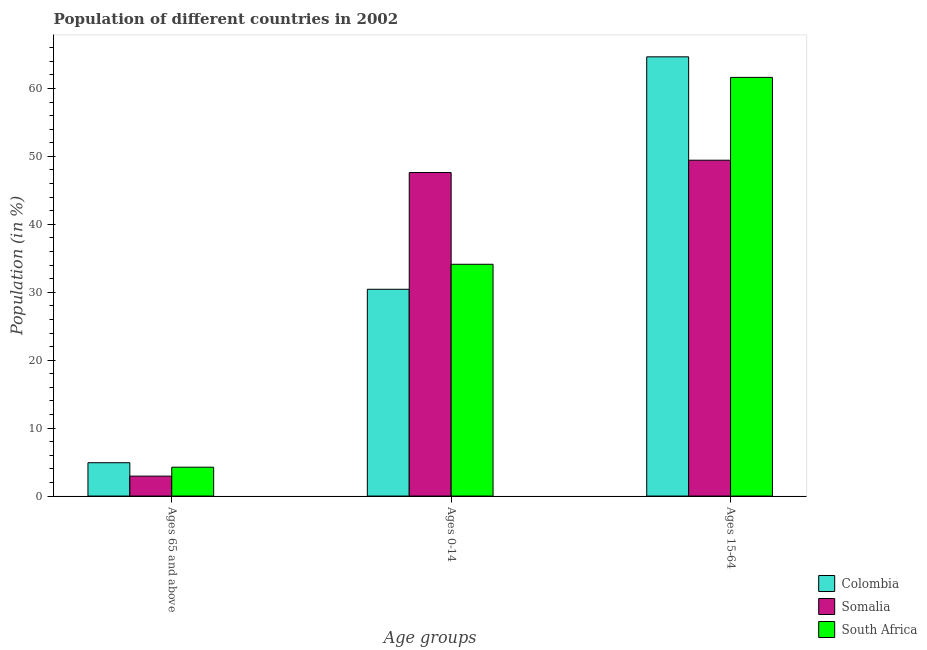How many different coloured bars are there?
Provide a short and direct response. 3. How many bars are there on the 2nd tick from the left?
Make the answer very short. 3. How many bars are there on the 3rd tick from the right?
Keep it short and to the point. 3. What is the label of the 2nd group of bars from the left?
Your answer should be compact. Ages 0-14. What is the percentage of population within the age-group of 65 and above in Somalia?
Ensure brevity in your answer.  2.94. Across all countries, what is the maximum percentage of population within the age-group 0-14?
Provide a succinct answer. 47.63. Across all countries, what is the minimum percentage of population within the age-group of 65 and above?
Ensure brevity in your answer.  2.94. In which country was the percentage of population within the age-group 0-14 maximum?
Make the answer very short. Somalia. In which country was the percentage of population within the age-group 0-14 minimum?
Your answer should be very brief. Colombia. What is the total percentage of population within the age-group 0-14 in the graph?
Your answer should be compact. 112.18. What is the difference between the percentage of population within the age-group of 65 and above in South Africa and that in Colombia?
Your answer should be very brief. -0.66. What is the difference between the percentage of population within the age-group of 65 and above in South Africa and the percentage of population within the age-group 0-14 in Colombia?
Offer a very short reply. -26.19. What is the average percentage of population within the age-group 0-14 per country?
Make the answer very short. 37.39. What is the difference between the percentage of population within the age-group 15-64 and percentage of population within the age-group of 65 and above in South Africa?
Your answer should be compact. 57.38. In how many countries, is the percentage of population within the age-group of 65 and above greater than 54 %?
Make the answer very short. 0. What is the ratio of the percentage of population within the age-group of 65 and above in South Africa to that in Colombia?
Ensure brevity in your answer.  0.87. Is the percentage of population within the age-group 0-14 in Colombia less than that in South Africa?
Provide a short and direct response. Yes. Is the difference between the percentage of population within the age-group 0-14 in South Africa and Somalia greater than the difference between the percentage of population within the age-group of 65 and above in South Africa and Somalia?
Keep it short and to the point. No. What is the difference between the highest and the second highest percentage of population within the age-group 15-64?
Give a very brief answer. 3.02. What is the difference between the highest and the lowest percentage of population within the age-group of 65 and above?
Keep it short and to the point. 1.97. What does the 2nd bar from the left in Ages 65 and above represents?
Keep it short and to the point. Somalia. What does the 2nd bar from the right in Ages 15-64 represents?
Your answer should be very brief. Somalia. Are all the bars in the graph horizontal?
Your answer should be compact. No. How many countries are there in the graph?
Your answer should be very brief. 3. Are the values on the major ticks of Y-axis written in scientific E-notation?
Keep it short and to the point. No. Where does the legend appear in the graph?
Your response must be concise. Bottom right. How many legend labels are there?
Keep it short and to the point. 3. What is the title of the graph?
Keep it short and to the point. Population of different countries in 2002. What is the label or title of the X-axis?
Your answer should be very brief. Age groups. What is the label or title of the Y-axis?
Offer a terse response. Population (in %). What is the Population (in %) of Colombia in Ages 65 and above?
Offer a terse response. 4.91. What is the Population (in %) of Somalia in Ages 65 and above?
Offer a terse response. 2.94. What is the Population (in %) in South Africa in Ages 65 and above?
Offer a very short reply. 4.25. What is the Population (in %) in Colombia in Ages 0-14?
Your answer should be very brief. 30.44. What is the Population (in %) of Somalia in Ages 0-14?
Give a very brief answer. 47.63. What is the Population (in %) in South Africa in Ages 0-14?
Provide a short and direct response. 34.12. What is the Population (in %) in Colombia in Ages 15-64?
Offer a terse response. 64.65. What is the Population (in %) in Somalia in Ages 15-64?
Keep it short and to the point. 49.44. What is the Population (in %) of South Africa in Ages 15-64?
Give a very brief answer. 61.63. Across all Age groups, what is the maximum Population (in %) of Colombia?
Your answer should be very brief. 64.65. Across all Age groups, what is the maximum Population (in %) of Somalia?
Your response must be concise. 49.44. Across all Age groups, what is the maximum Population (in %) in South Africa?
Your answer should be compact. 61.63. Across all Age groups, what is the minimum Population (in %) of Colombia?
Ensure brevity in your answer.  4.91. Across all Age groups, what is the minimum Population (in %) of Somalia?
Your answer should be very brief. 2.94. Across all Age groups, what is the minimum Population (in %) in South Africa?
Offer a terse response. 4.25. What is the total Population (in %) in Somalia in the graph?
Ensure brevity in your answer.  100. What is the total Population (in %) in South Africa in the graph?
Your answer should be very brief. 100. What is the difference between the Population (in %) in Colombia in Ages 65 and above and that in Ages 0-14?
Your response must be concise. -25.53. What is the difference between the Population (in %) of Somalia in Ages 65 and above and that in Ages 0-14?
Offer a terse response. -44.69. What is the difference between the Population (in %) in South Africa in Ages 65 and above and that in Ages 0-14?
Your response must be concise. -29.87. What is the difference between the Population (in %) of Colombia in Ages 65 and above and that in Ages 15-64?
Offer a very short reply. -59.75. What is the difference between the Population (in %) of Somalia in Ages 65 and above and that in Ages 15-64?
Provide a succinct answer. -46.5. What is the difference between the Population (in %) in South Africa in Ages 65 and above and that in Ages 15-64?
Offer a terse response. -57.38. What is the difference between the Population (in %) in Colombia in Ages 0-14 and that in Ages 15-64?
Offer a very short reply. -34.22. What is the difference between the Population (in %) in Somalia in Ages 0-14 and that in Ages 15-64?
Give a very brief answer. -1.81. What is the difference between the Population (in %) of South Africa in Ages 0-14 and that in Ages 15-64?
Offer a terse response. -27.51. What is the difference between the Population (in %) of Colombia in Ages 65 and above and the Population (in %) of Somalia in Ages 0-14?
Ensure brevity in your answer.  -42.72. What is the difference between the Population (in %) in Colombia in Ages 65 and above and the Population (in %) in South Africa in Ages 0-14?
Keep it short and to the point. -29.21. What is the difference between the Population (in %) of Somalia in Ages 65 and above and the Population (in %) of South Africa in Ages 0-14?
Provide a short and direct response. -31.18. What is the difference between the Population (in %) in Colombia in Ages 65 and above and the Population (in %) in Somalia in Ages 15-64?
Your answer should be very brief. -44.53. What is the difference between the Population (in %) in Colombia in Ages 65 and above and the Population (in %) in South Africa in Ages 15-64?
Keep it short and to the point. -56.72. What is the difference between the Population (in %) of Somalia in Ages 65 and above and the Population (in %) of South Africa in Ages 15-64?
Your answer should be very brief. -58.69. What is the difference between the Population (in %) in Colombia in Ages 0-14 and the Population (in %) in Somalia in Ages 15-64?
Ensure brevity in your answer.  -19. What is the difference between the Population (in %) of Colombia in Ages 0-14 and the Population (in %) of South Africa in Ages 15-64?
Offer a very short reply. -31.19. What is the difference between the Population (in %) in Somalia in Ages 0-14 and the Population (in %) in South Africa in Ages 15-64?
Keep it short and to the point. -14. What is the average Population (in %) of Colombia per Age groups?
Your answer should be very brief. 33.33. What is the average Population (in %) in Somalia per Age groups?
Keep it short and to the point. 33.33. What is the average Population (in %) of South Africa per Age groups?
Give a very brief answer. 33.33. What is the difference between the Population (in %) of Colombia and Population (in %) of Somalia in Ages 65 and above?
Offer a terse response. 1.97. What is the difference between the Population (in %) in Colombia and Population (in %) in South Africa in Ages 65 and above?
Your answer should be compact. 0.66. What is the difference between the Population (in %) of Somalia and Population (in %) of South Africa in Ages 65 and above?
Your response must be concise. -1.31. What is the difference between the Population (in %) in Colombia and Population (in %) in Somalia in Ages 0-14?
Offer a terse response. -17.19. What is the difference between the Population (in %) of Colombia and Population (in %) of South Africa in Ages 0-14?
Your answer should be very brief. -3.68. What is the difference between the Population (in %) in Somalia and Population (in %) in South Africa in Ages 0-14?
Your answer should be compact. 13.51. What is the difference between the Population (in %) in Colombia and Population (in %) in Somalia in Ages 15-64?
Your answer should be compact. 15.22. What is the difference between the Population (in %) in Colombia and Population (in %) in South Africa in Ages 15-64?
Provide a succinct answer. 3.02. What is the difference between the Population (in %) of Somalia and Population (in %) of South Africa in Ages 15-64?
Give a very brief answer. -12.19. What is the ratio of the Population (in %) in Colombia in Ages 65 and above to that in Ages 0-14?
Your response must be concise. 0.16. What is the ratio of the Population (in %) of Somalia in Ages 65 and above to that in Ages 0-14?
Give a very brief answer. 0.06. What is the ratio of the Population (in %) of South Africa in Ages 65 and above to that in Ages 0-14?
Ensure brevity in your answer.  0.12. What is the ratio of the Population (in %) of Colombia in Ages 65 and above to that in Ages 15-64?
Your response must be concise. 0.08. What is the ratio of the Population (in %) in Somalia in Ages 65 and above to that in Ages 15-64?
Your answer should be very brief. 0.06. What is the ratio of the Population (in %) of South Africa in Ages 65 and above to that in Ages 15-64?
Offer a terse response. 0.07. What is the ratio of the Population (in %) of Colombia in Ages 0-14 to that in Ages 15-64?
Ensure brevity in your answer.  0.47. What is the ratio of the Population (in %) of Somalia in Ages 0-14 to that in Ages 15-64?
Your response must be concise. 0.96. What is the ratio of the Population (in %) in South Africa in Ages 0-14 to that in Ages 15-64?
Your answer should be compact. 0.55. What is the difference between the highest and the second highest Population (in %) of Colombia?
Your answer should be very brief. 34.22. What is the difference between the highest and the second highest Population (in %) of Somalia?
Your response must be concise. 1.81. What is the difference between the highest and the second highest Population (in %) in South Africa?
Give a very brief answer. 27.51. What is the difference between the highest and the lowest Population (in %) of Colombia?
Your answer should be very brief. 59.75. What is the difference between the highest and the lowest Population (in %) of Somalia?
Ensure brevity in your answer.  46.5. What is the difference between the highest and the lowest Population (in %) of South Africa?
Ensure brevity in your answer.  57.38. 